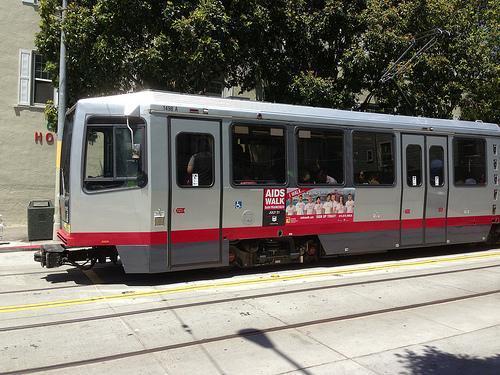How many buses on the road?
Give a very brief answer. 1. 